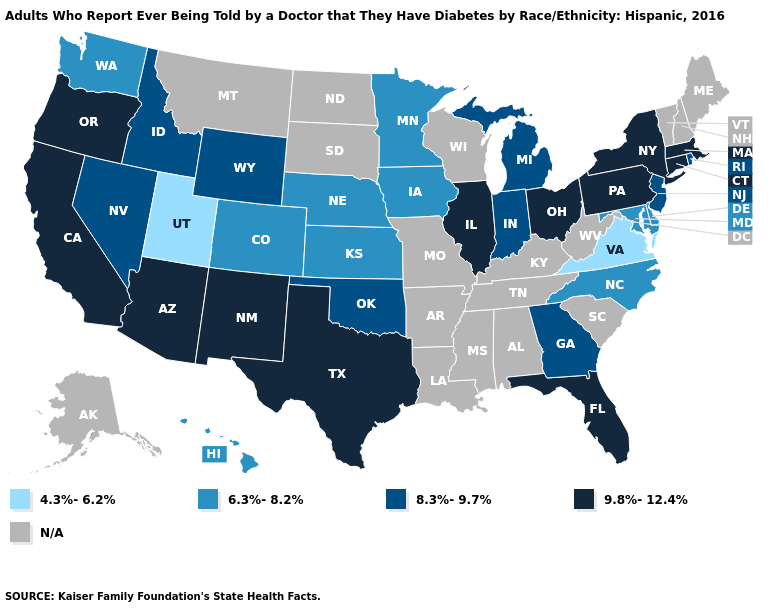What is the value of Idaho?
Write a very short answer. 8.3%-9.7%. Name the states that have a value in the range 4.3%-6.2%?
Keep it brief. Utah, Virginia. What is the value of New York?
Answer briefly. 9.8%-12.4%. Which states have the highest value in the USA?
Write a very short answer. Arizona, California, Connecticut, Florida, Illinois, Massachusetts, New Mexico, New York, Ohio, Oregon, Pennsylvania, Texas. What is the lowest value in the West?
Keep it brief. 4.3%-6.2%. What is the value of Michigan?
Be succinct. 8.3%-9.7%. Among the states that border Arizona , does Nevada have the highest value?
Short answer required. No. What is the value of Oregon?
Short answer required. 9.8%-12.4%. Does Florida have the highest value in the South?
Concise answer only. Yes. What is the value of South Carolina?
Answer briefly. N/A. Name the states that have a value in the range 4.3%-6.2%?
Concise answer only. Utah, Virginia. Name the states that have a value in the range 9.8%-12.4%?
Write a very short answer. Arizona, California, Connecticut, Florida, Illinois, Massachusetts, New Mexico, New York, Ohio, Oregon, Pennsylvania, Texas. What is the value of Mississippi?
Write a very short answer. N/A. 